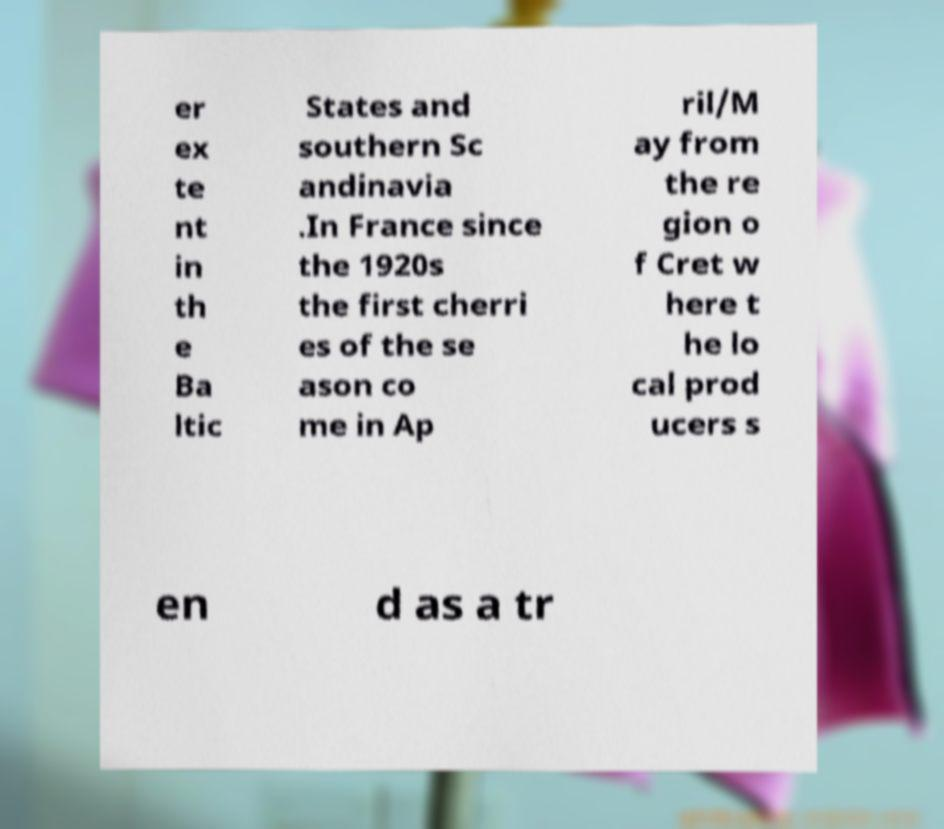Please read and relay the text visible in this image. What does it say? er ex te nt in th e Ba ltic States and southern Sc andinavia .In France since the 1920s the first cherri es of the se ason co me in Ap ril/M ay from the re gion o f Cret w here t he lo cal prod ucers s en d as a tr 